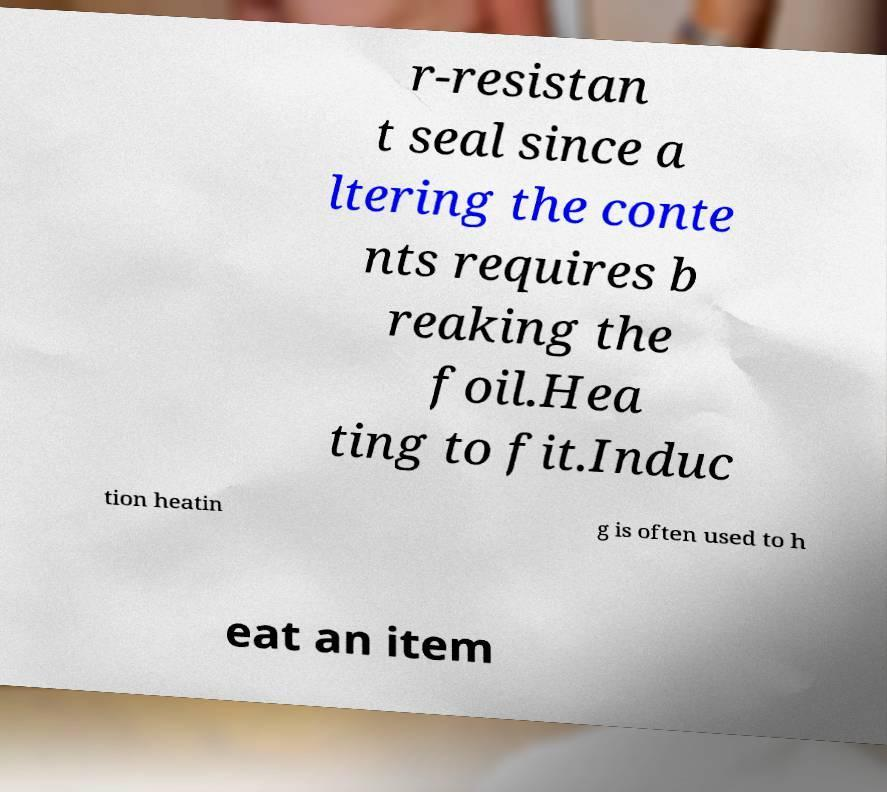There's text embedded in this image that I need extracted. Can you transcribe it verbatim? r-resistan t seal since a ltering the conte nts requires b reaking the foil.Hea ting to fit.Induc tion heatin g is often used to h eat an item 